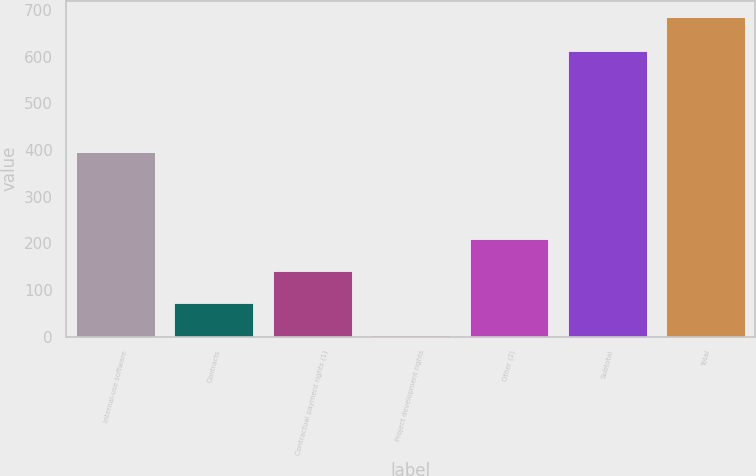Convert chart to OTSL. <chart><loc_0><loc_0><loc_500><loc_500><bar_chart><fcel>Internal-use software<fcel>Contracts<fcel>Contractual payment rights (1)<fcel>Project development rights<fcel>Other (2)<fcel>Subtotal<fcel>Total<nl><fcel>396<fcel>72.2<fcel>140.4<fcel>4<fcel>208.6<fcel>612<fcel>686<nl></chart> 